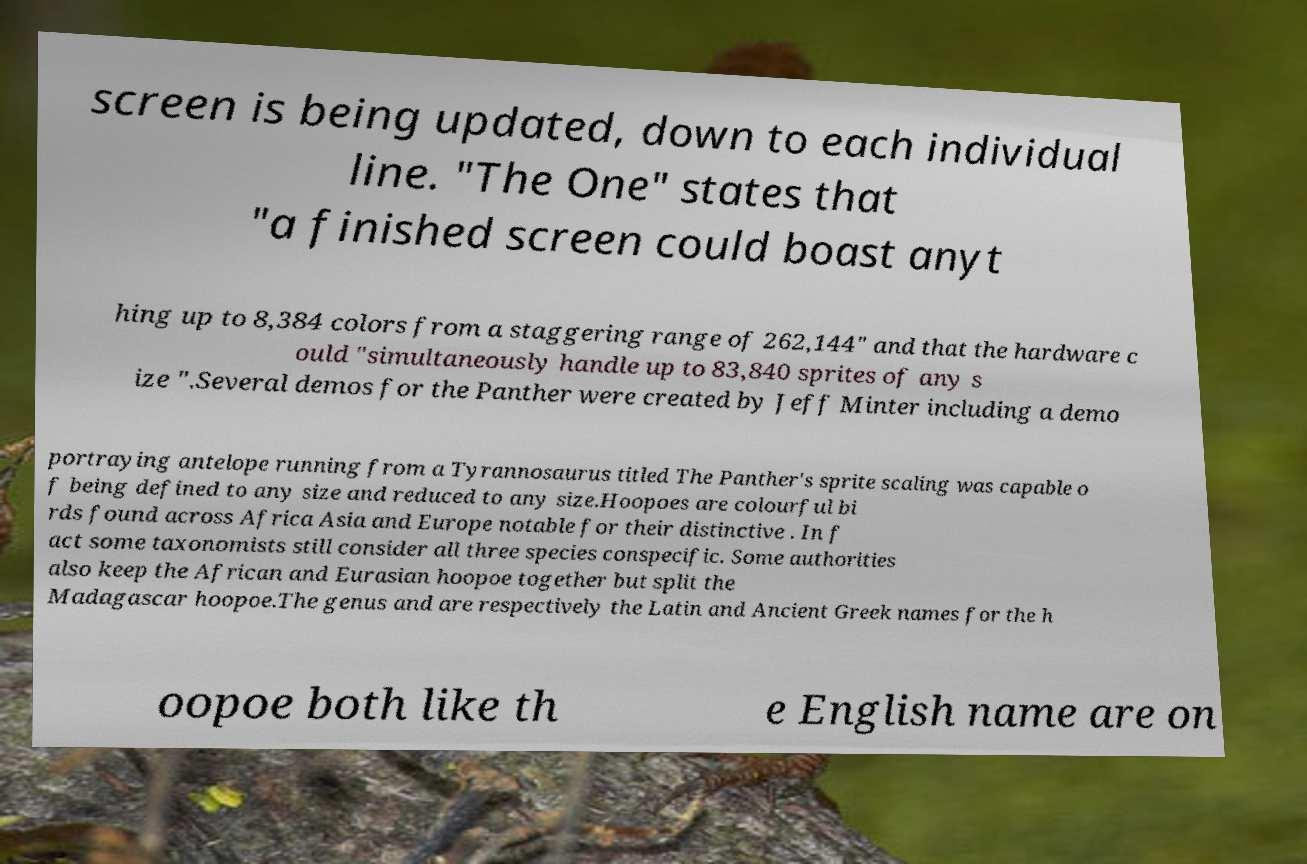Can you accurately transcribe the text from the provided image for me? screen is being updated, down to each individual line. "The One" states that "a finished screen could boast anyt hing up to 8,384 colors from a staggering range of 262,144" and that the hardware c ould "simultaneously handle up to 83,840 sprites of any s ize ".Several demos for the Panther were created by Jeff Minter including a demo portraying antelope running from a Tyrannosaurus titled The Panther's sprite scaling was capable o f being defined to any size and reduced to any size.Hoopoes are colourful bi rds found across Africa Asia and Europe notable for their distinctive . In f act some taxonomists still consider all three species conspecific. Some authorities also keep the African and Eurasian hoopoe together but split the Madagascar hoopoe.The genus and are respectively the Latin and Ancient Greek names for the h oopoe both like th e English name are on 